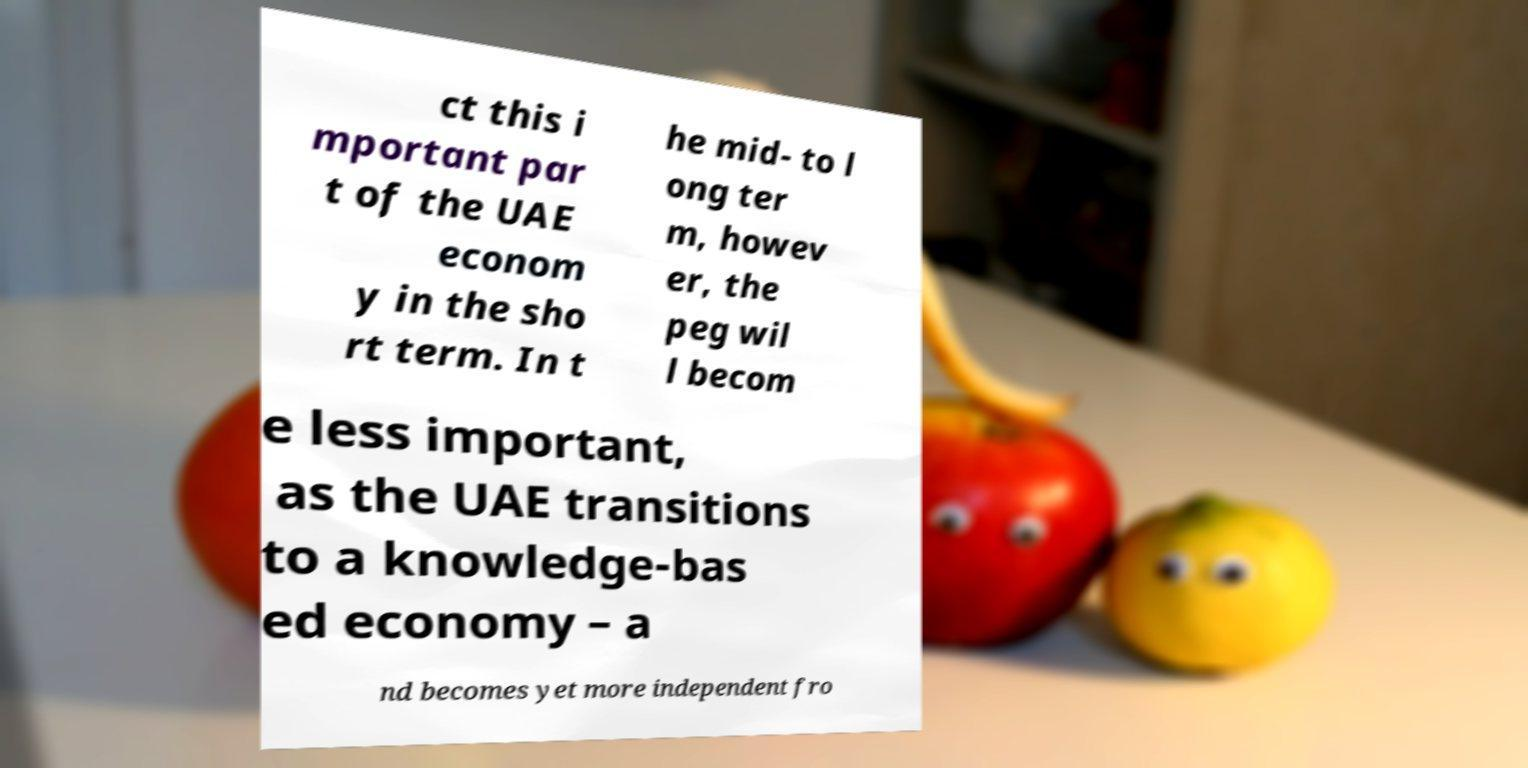I need the written content from this picture converted into text. Can you do that? ct this i mportant par t of the UAE econom y in the sho rt term. In t he mid- to l ong ter m, howev er, the peg wil l becom e less important, as the UAE transitions to a knowledge-bas ed economy – a nd becomes yet more independent fro 